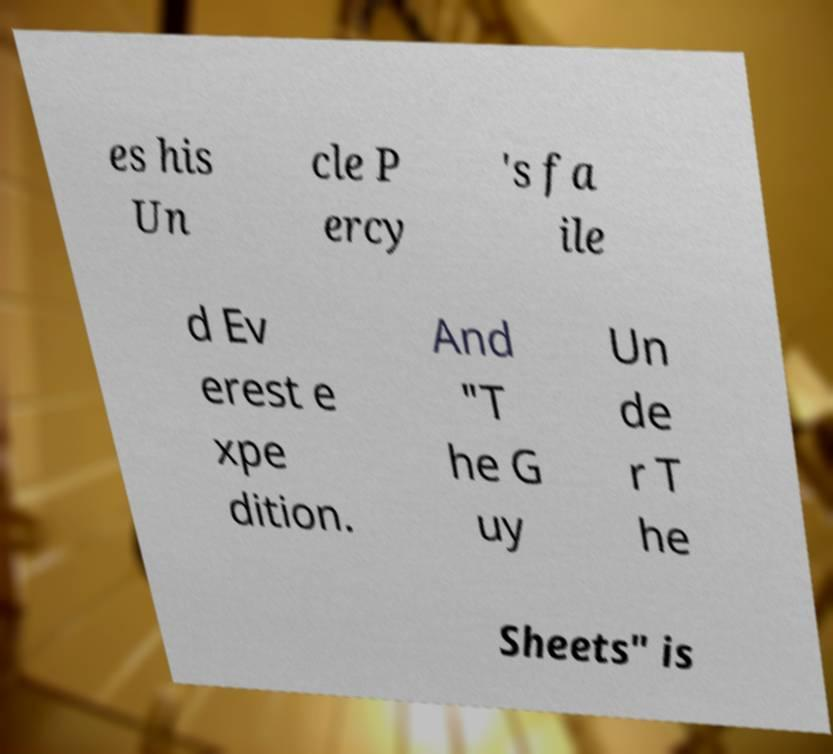Could you extract and type out the text from this image? es his Un cle P ercy 's fa ile d Ev erest e xpe dition. And "T he G uy Un de r T he Sheets" is 